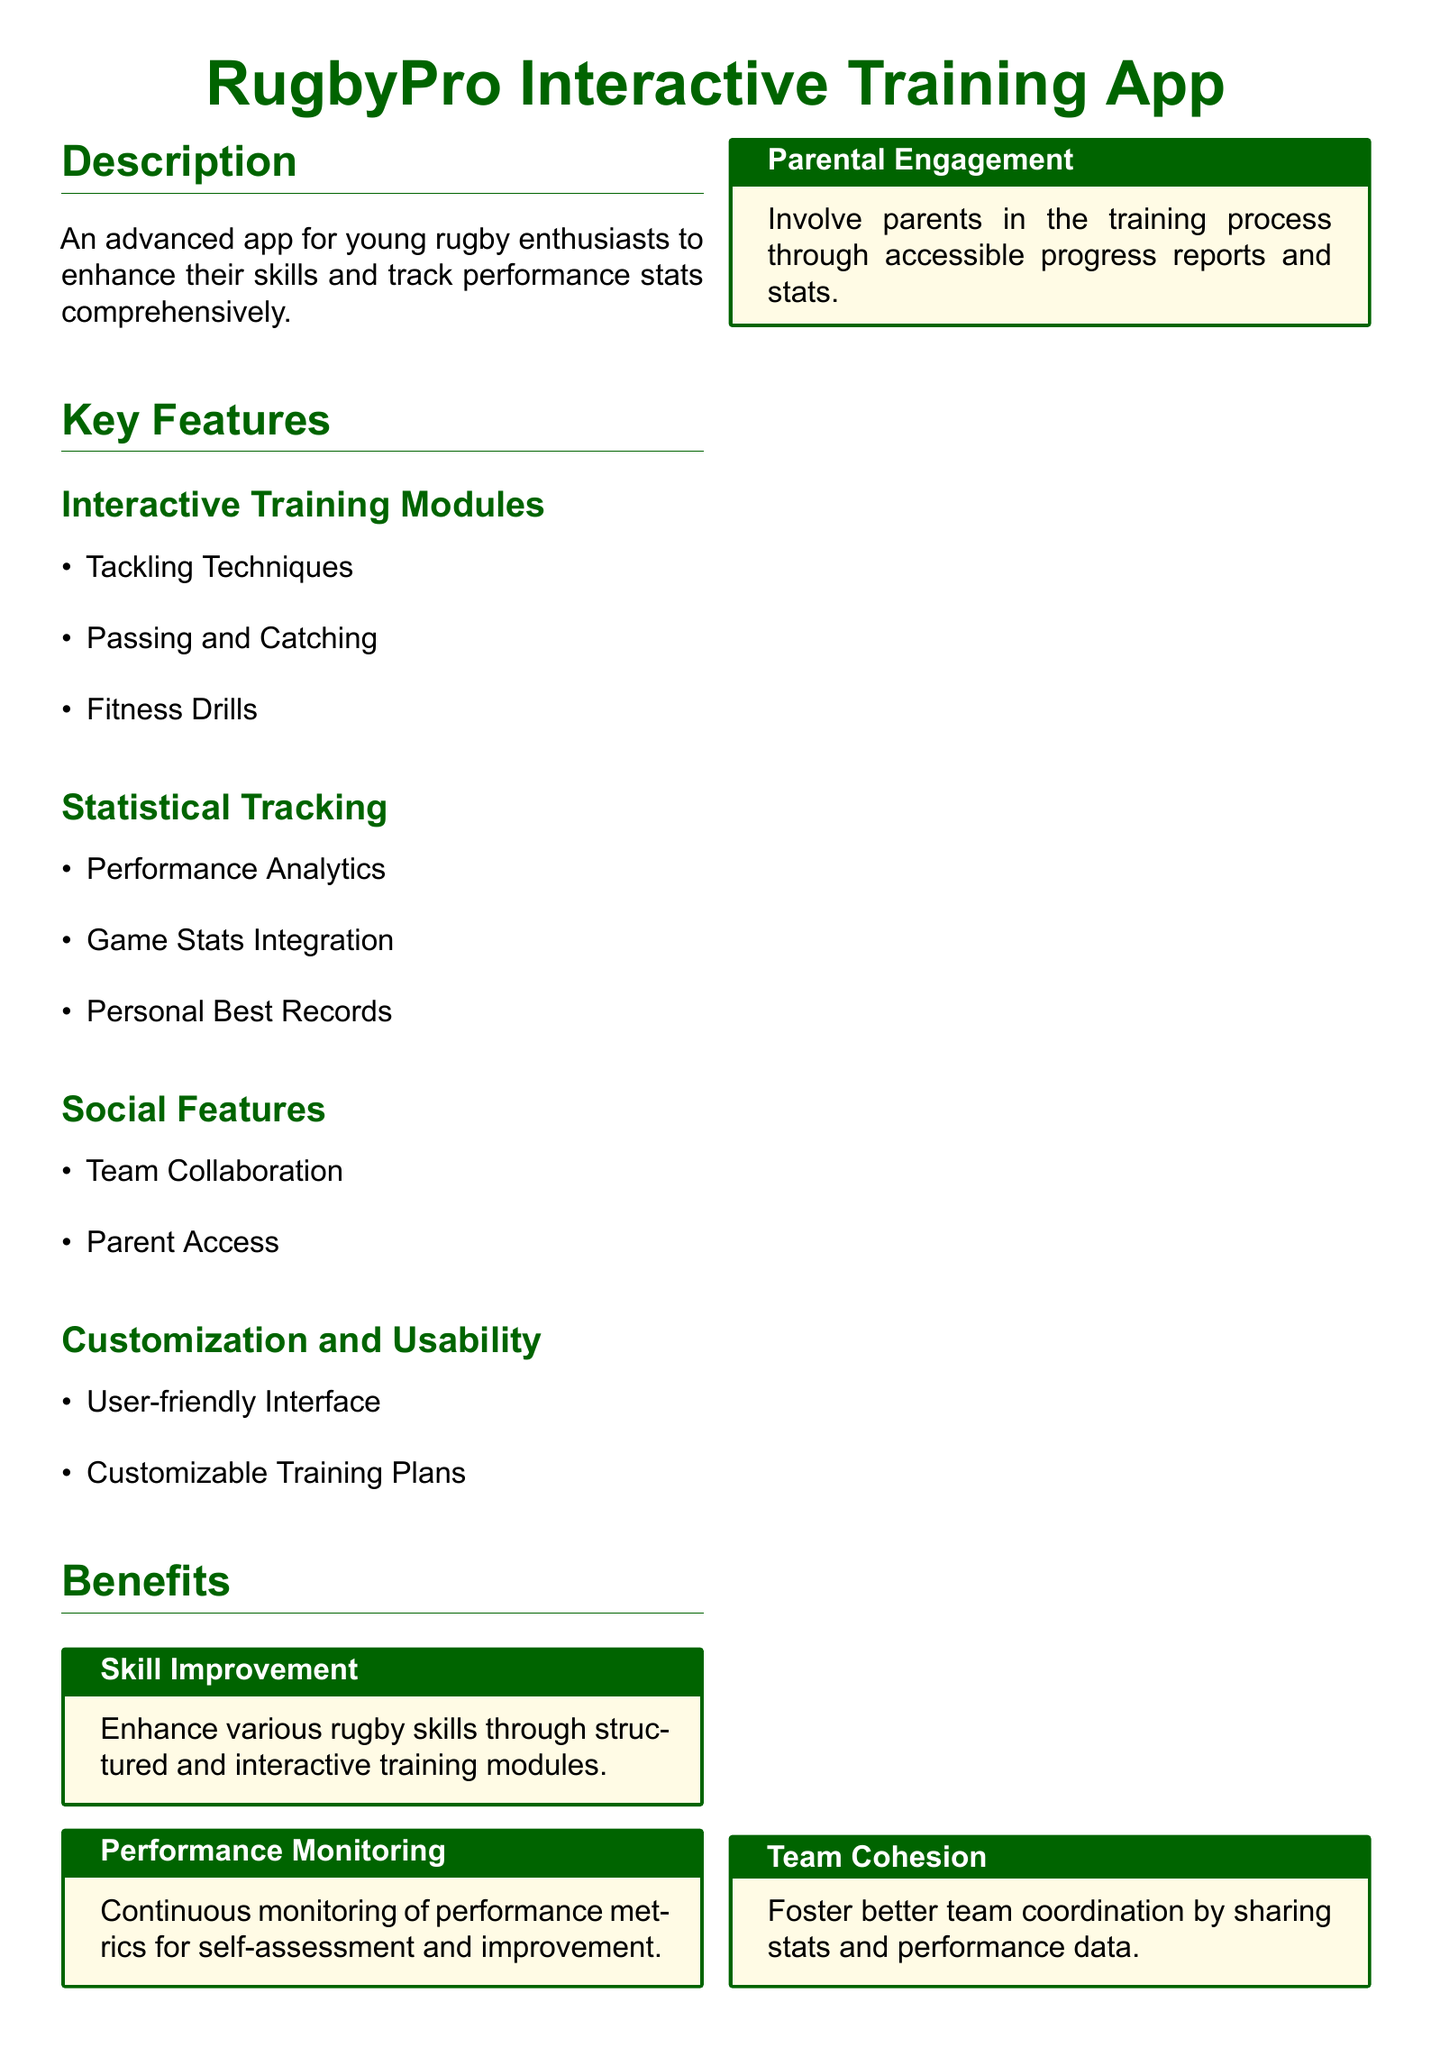What is the name of the app? The name of the app is explicitly stated at the top of the document as "RugbyPro Interactive Training App."
Answer: RugbyPro Interactive Training App Who is the target audience for this app? The target audience is specified in the document as two groups: young rugby players and parents and coaches.
Answer: Young Rugby Players and Parents and Coaches What age group does the app focus on? The app specifically targets boys and girls aged 12 to 18 as indicated in the document under the target audience section.
Answer: 12-18 What feature is mentioned for performance metrics? The document lists "Performance Analytics" as a feature under the statistical tracking section.
Answer: Performance Analytics What is one benefit of the app related to skill improvement? The benefit is described in the document as enhancing various rugby skills through structured and interactive training modules.
Answer: Enhance various rugby skills What type of features does the app include for collaboration? The app includes "Team Collaboration" as one of its social features, fostering interaction among team members.
Answer: Team Collaboration What inspired the training modules in the app? The document mentions "Nike Training Club" as an inspiration for the interactive training and fitness modules.
Answer: Nike Training Club How does the app involve parents? The app involves parents through accessible progress reports and stats, as stated in the parental engagement benefit.
Answer: Access to progress reports and stats What color theme is used in the app's document? The document features a color theme defined by rugby green and rugby gold.
Answer: Rugby green and rugby gold 